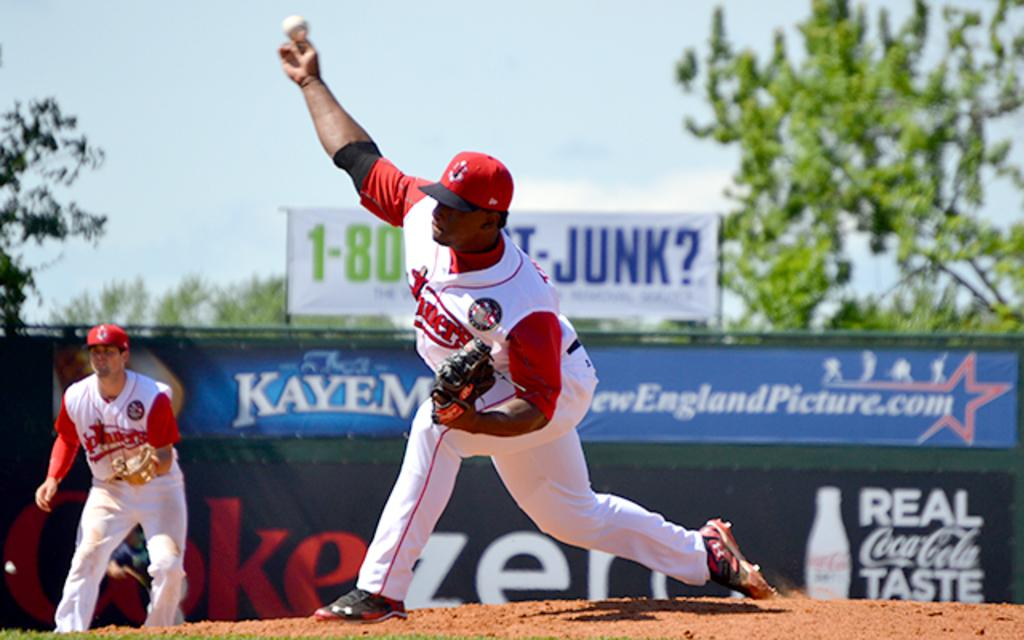<image>
Relay a brief, clear account of the picture shown. Baseball player wearing a white jersey that says miners. 